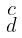<formula> <loc_0><loc_0><loc_500><loc_500>\begin{smallmatrix} c \\ d \end{smallmatrix}</formula> 